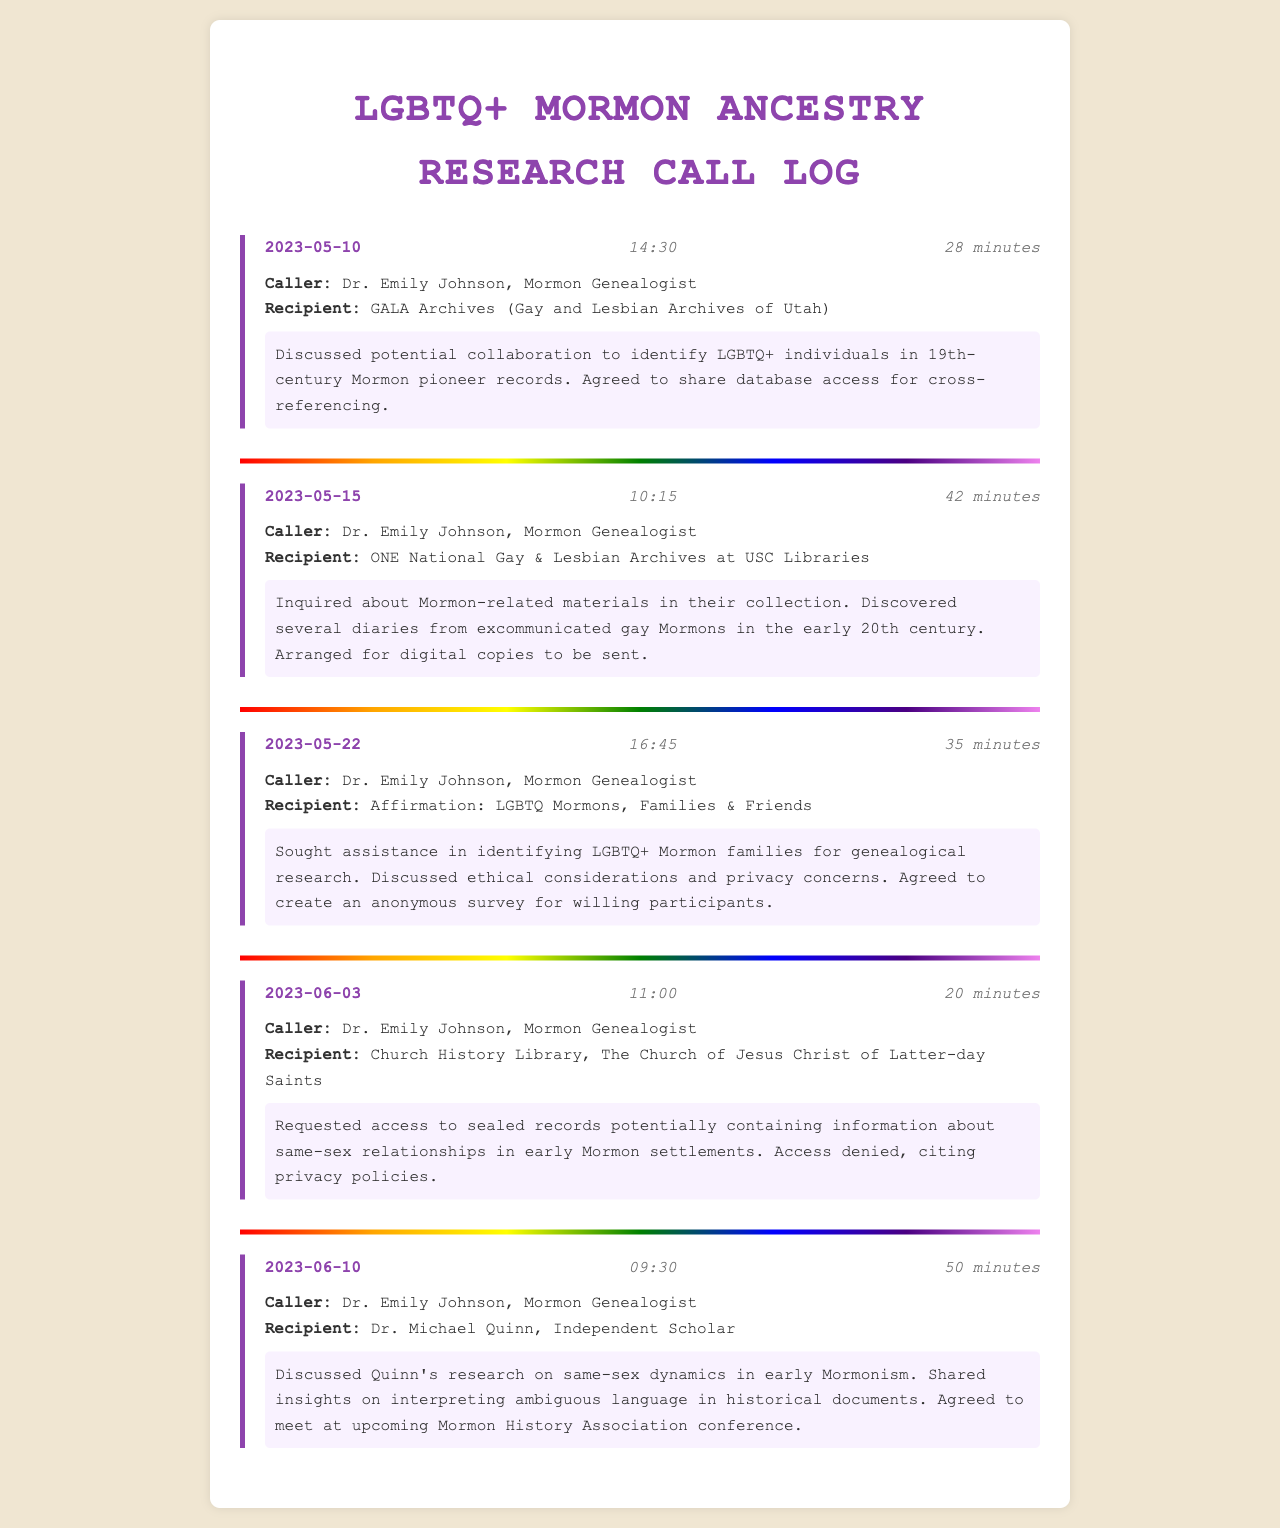What is the date of the first call? The first call occurred on May 10, 2023, as documented in the call log.
Answer: May 10, 2023 Who was the recipient of the call on May 15, 2023? The recipient of the call on May 15, 2023, was the ONE National Gay & Lesbian Archives at USC Libraries.
Answer: ONE National Gay & Lesbian Archives at USC Libraries How long was the call with Affirmation on May 22, 2023? The call with Affirmation lasted 35 minutes, as indicated in the document.
Answer: 35 minutes What was the main topic discussed in the call with GALA Archives? The main topic discussed was the potential collaboration to identify LGBTQ+ individuals in 19th-century Mormon pioneer records.
Answer: Collaboration to identify LGBTQ+ individuals Was access granted to the sealed records by the Church History Library? Access to the sealed records was denied, as mentioned in the call summary.
Answer: Denied What did Dr. Emily Johnson request in the call on June 3, 2023? Dr. Emily Johnson requested access to sealed records containing information about same-sex relationships.
Answer: Access to sealed records Which scholar did Dr. Emily Johnson discuss research with on June 10, 2023? Dr. Emily Johnson discussed research with Dr. Michael Quinn, an independent scholar.
Answer: Dr. Michael Quinn How many minutes did the call with GALA Archives last? The call with GALA Archives lasted 28 minutes according to the call log.
Answer: 28 minutes What did the call with Affirmation address regarding LGBTQ+ Mormon families? The call addressed ethical considerations and privacy concerns.
Answer: Ethical considerations and privacy concerns 